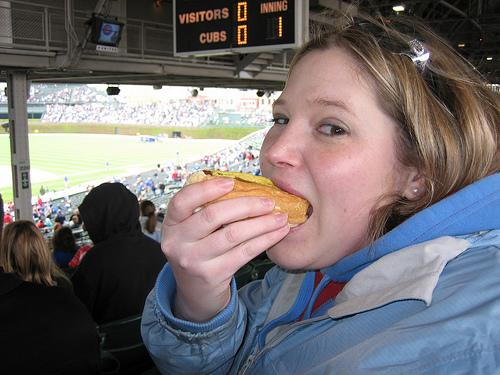Identify the purpose of the television objects in the image. The televisions display sports scores and other information for the spectators. Identify three aspects related to the woman's appearance. Wearing a light blue jacket, pearl earring, and silver barrette in her hair. List three objects related to the sporting event in order of appearance in the image. baseball diamond, small television with sports scores, baseball scoreboard What is a small accessory located in the woman's hair? A pair of glasses can be found in the woman's hair. What can be inferred about the baseball game based on the scoreboard? The game is in the first inning, and both teams have a score of 0. Provide a concise description of what the woman is doing in the image. A woman is eating a hot dog while wearing a light blue jacket at a baseball game. Give a brief description of the object held in the woman's hand. The woman's hand is holding a hotdog with a bun and mustard. Describe the sentiment or mood portrayed in the image. The image conveys a fun and relaxed atmosphere, with people enjoying a baseball game and snacks. Describe the object associated with the numbers 00. The number 00 is on the scoreboard, indicating the scores for both teams. 